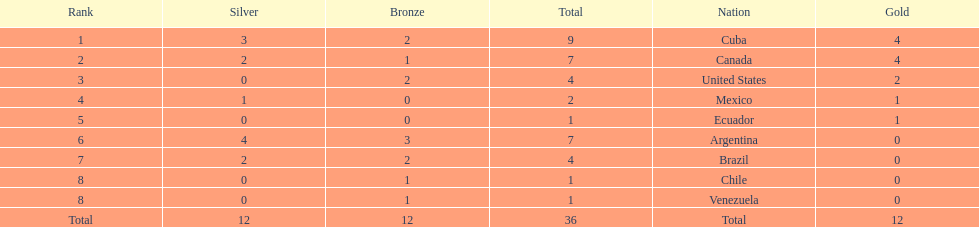What is the overall count of countries that failed to secure gold? 4. 